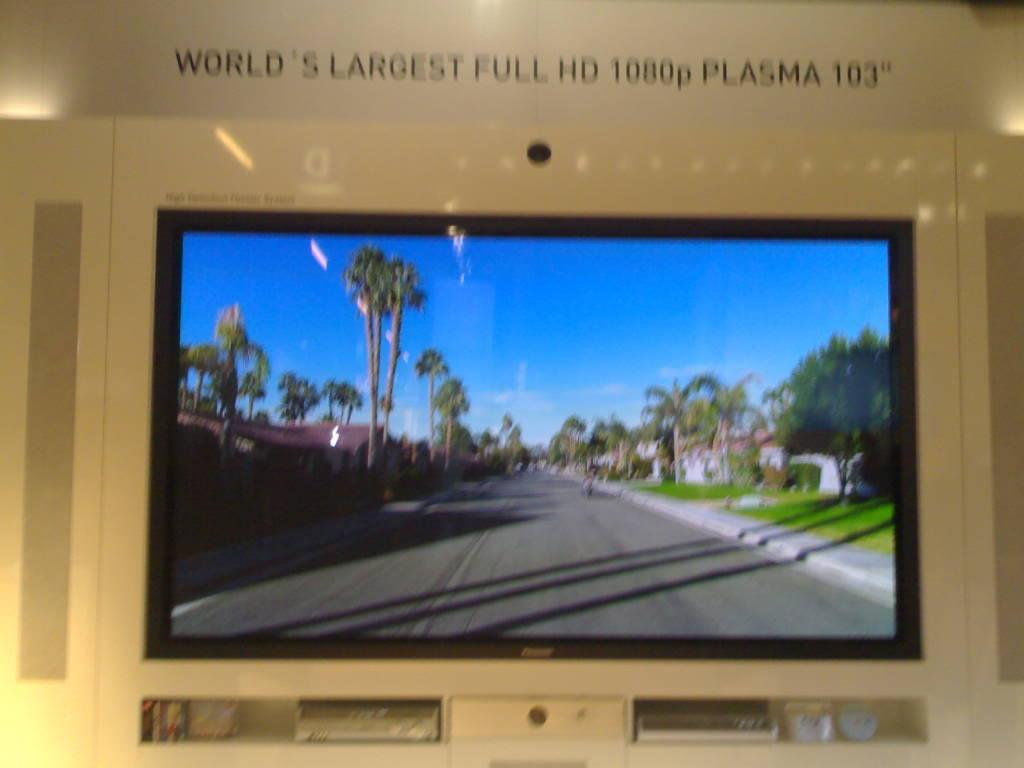<image>
Share a concise interpretation of the image provided. Small screen showing palm trees and the number 1080 above. 